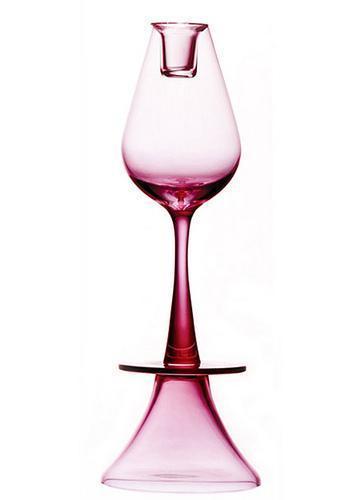How many objects are in the photo?
Give a very brief answer. 1. How many different colors are in the photo?
Give a very brief answer. 2. How many different examples of liquor glassware are built into this?
Give a very brief answer. 3. 